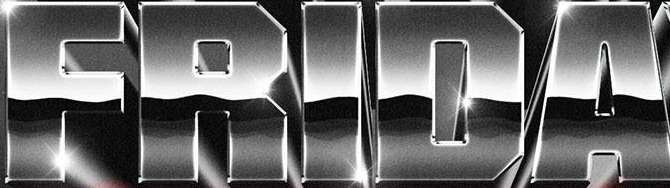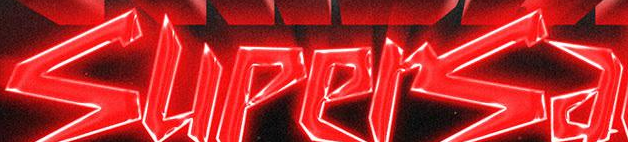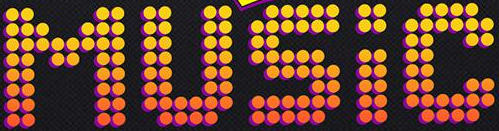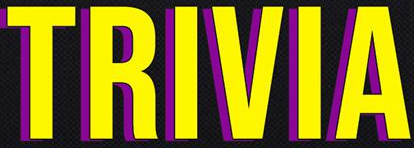What words can you see in these images in sequence, separated by a semicolon? FRIDA; supersa; MUSIC; TRIVIA 